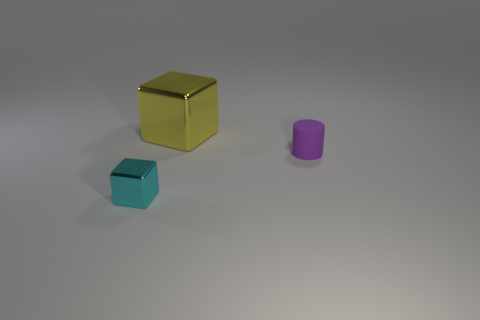Add 3 shiny blocks. How many objects exist? 6 Subtract all cylinders. How many objects are left? 2 Add 3 small cyan metallic things. How many small cyan metallic things exist? 4 Subtract 0 brown spheres. How many objects are left? 3 Subtract all tiny matte cylinders. Subtract all tiny cylinders. How many objects are left? 1 Add 2 large yellow objects. How many large yellow objects are left? 3 